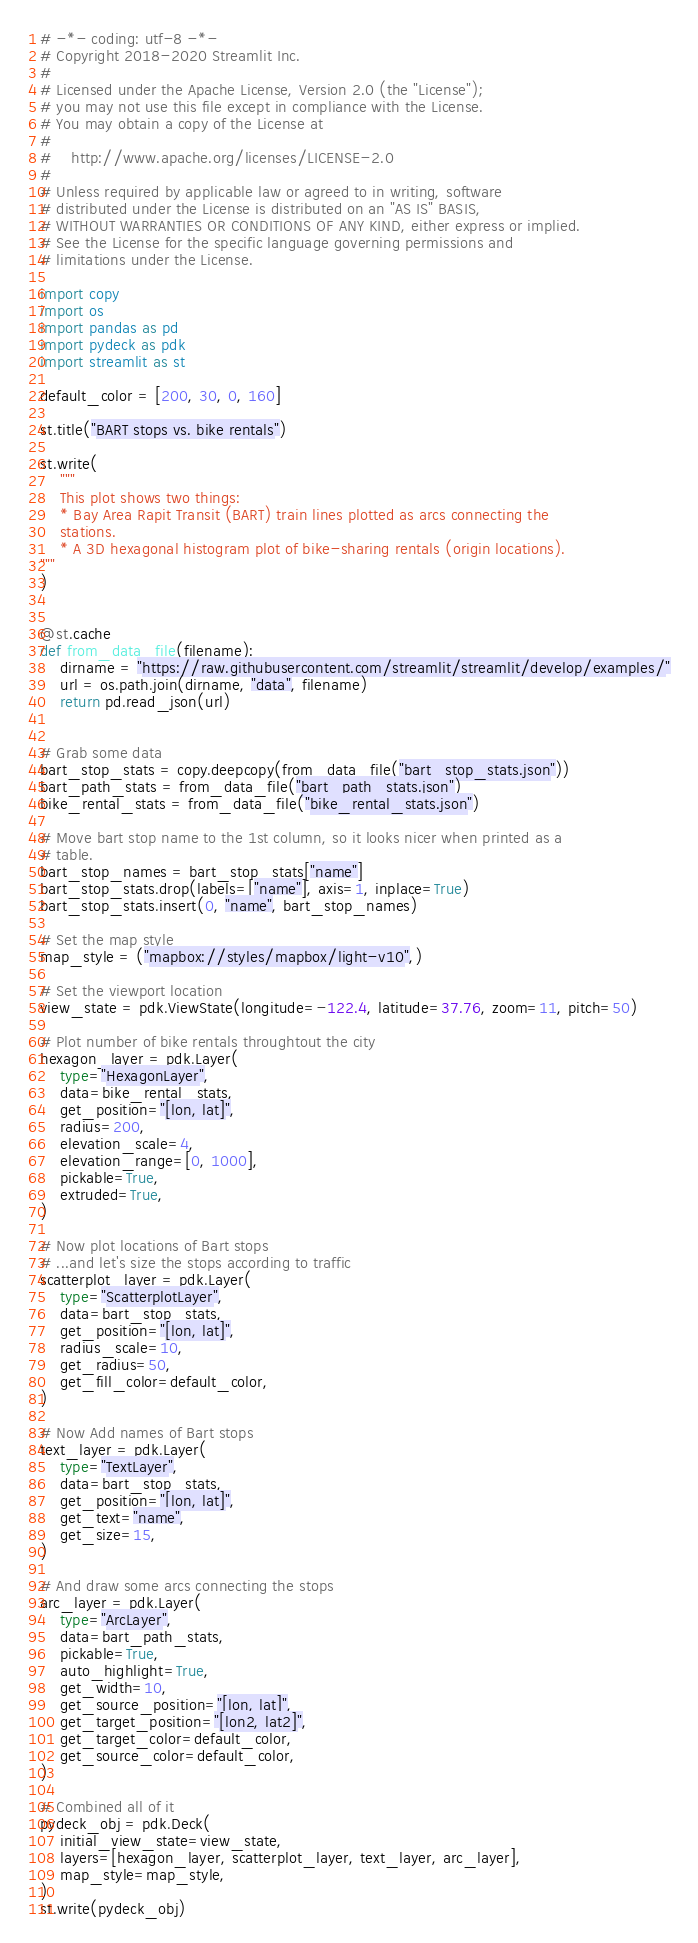<code> <loc_0><loc_0><loc_500><loc_500><_Python_># -*- coding: utf-8 -*-
# Copyright 2018-2020 Streamlit Inc.
#
# Licensed under the Apache License, Version 2.0 (the "License");
# you may not use this file except in compliance with the License.
# You may obtain a copy of the License at
#
#    http://www.apache.org/licenses/LICENSE-2.0
#
# Unless required by applicable law or agreed to in writing, software
# distributed under the License is distributed on an "AS IS" BASIS,
# WITHOUT WARRANTIES OR CONDITIONS OF ANY KIND, either express or implied.
# See the License for the specific language governing permissions and
# limitations under the License.

import copy
import os
import pandas as pd
import pydeck as pdk
import streamlit as st

default_color = [200, 30, 0, 160]

st.title("BART stops vs. bike rentals")

st.write(
    """
    This plot shows two things:
    * Bay Area Rapit Transit (BART) train lines plotted as arcs connecting the
    stations.
    * A 3D hexagonal histogram plot of bike-sharing rentals (origin locations).
"""
)


@st.cache
def from_data_file(filename):
    dirname = "https://raw.githubusercontent.com/streamlit/streamlit/develop/examples/"
    url = os.path.join(dirname, "data", filename)
    return pd.read_json(url)


# Grab some data
bart_stop_stats = copy.deepcopy(from_data_file("bart_stop_stats.json"))
bart_path_stats = from_data_file("bart_path_stats.json")
bike_rental_stats = from_data_file("bike_rental_stats.json")

# Move bart stop name to the 1st column, so it looks nicer when printed as a
# table.
bart_stop_names = bart_stop_stats["name"]
bart_stop_stats.drop(labels=["name"], axis=1, inplace=True)
bart_stop_stats.insert(0, "name", bart_stop_names)

# Set the map style
map_style = ("mapbox://styles/mapbox/light-v10",)

# Set the viewport location
view_state = pdk.ViewState(longitude=-122.4, latitude=37.76, zoom=11, pitch=50)

# Plot number of bike rentals throughtout the city
hexagon_layer = pdk.Layer(
    type="HexagonLayer",
    data=bike_rental_stats,
    get_position="[lon, lat]",
    radius=200,
    elevation_scale=4,
    elevation_range=[0, 1000],
    pickable=True,
    extruded=True,
)

# Now plot locations of Bart stops
# ...and let's size the stops according to traffic
scatterplot_layer = pdk.Layer(
    type="ScatterplotLayer",
    data=bart_stop_stats,
    get_position="[lon, lat]",
    radius_scale=10,
    get_radius=50,
    get_fill_color=default_color,
)

# Now Add names of Bart stops
text_layer = pdk.Layer(
    type="TextLayer",
    data=bart_stop_stats,
    get_position="[lon, lat]",
    get_text="name",
    get_size=15,
)

# And draw some arcs connecting the stops
arc_layer = pdk.Layer(
    type="ArcLayer",
    data=bart_path_stats,
    pickable=True,
    auto_highlight=True,
    get_width=10,
    get_source_position="[lon, lat]",
    get_target_position="[lon2, lat2]",
    get_target_color=default_color,
    get_source_color=default_color,
)

# Combined all of it
pydeck_obj = pdk.Deck(
    initial_view_state=view_state,
    layers=[hexagon_layer, scatterplot_layer, text_layer, arc_layer],
    map_style=map_style,
)
st.write(pydeck_obj)
</code> 